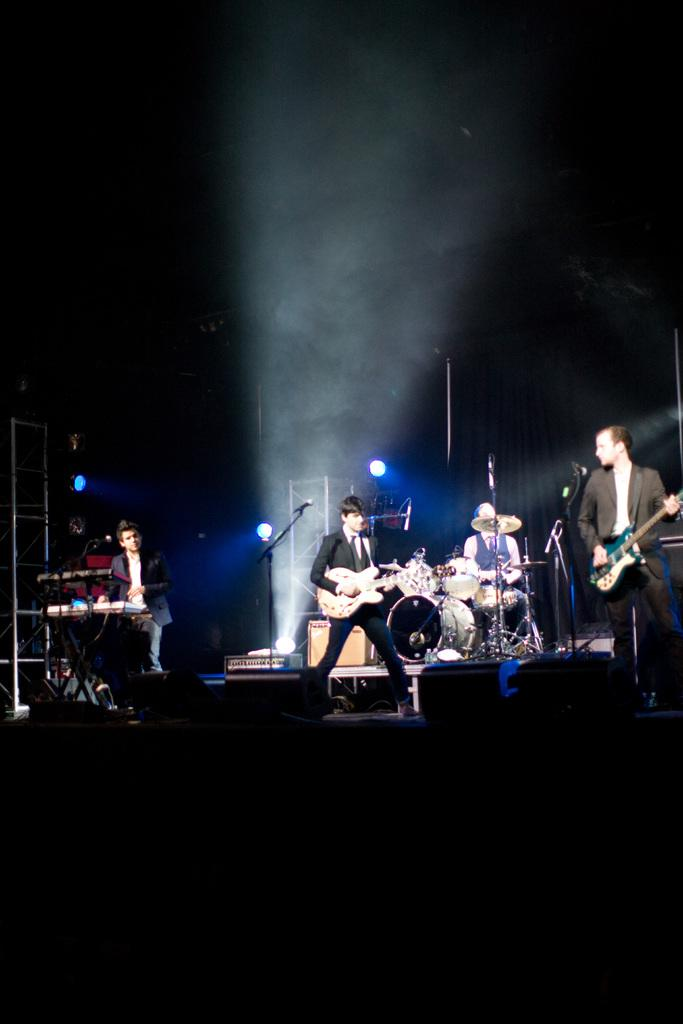How many people are in the image? There are four people in the image. What are the people doing in the image? The people are musicians. What objects are in front of the musicians? There are musical instruments in front of the people. What can be seen in the background of the image? There are lights visible in the background of the image. What type of drum can be seen in the image? There is no drum present in the image. Can you tell me how many planes are flying in the background of the image? There are no planes visible in the image; only lights can be seen in the background. 